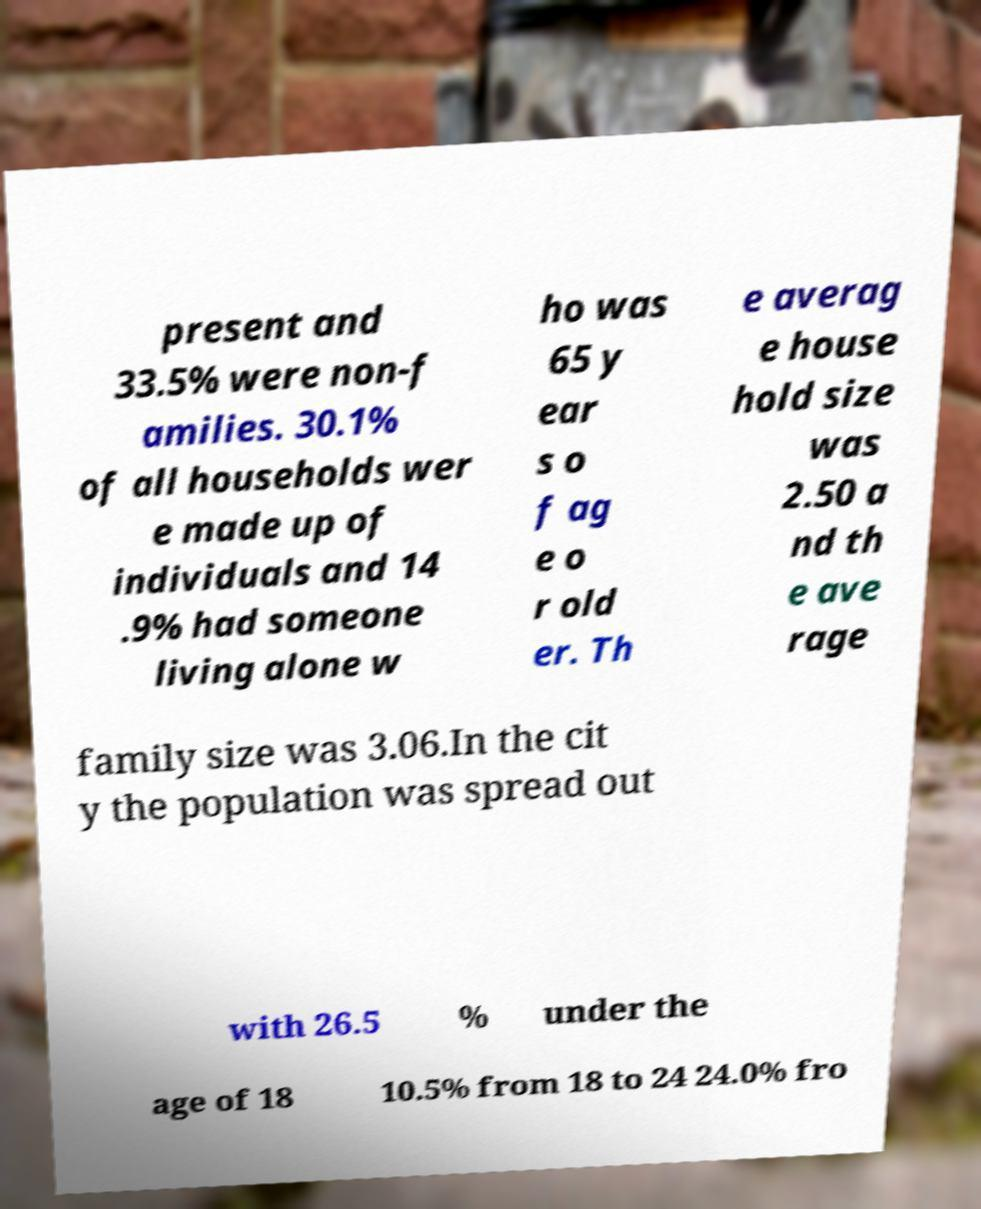There's text embedded in this image that I need extracted. Can you transcribe it verbatim? present and 33.5% were non-f amilies. 30.1% of all households wer e made up of individuals and 14 .9% had someone living alone w ho was 65 y ear s o f ag e o r old er. Th e averag e house hold size was 2.50 a nd th e ave rage family size was 3.06.In the cit y the population was spread out with 26.5 % under the age of 18 10.5% from 18 to 24 24.0% fro 